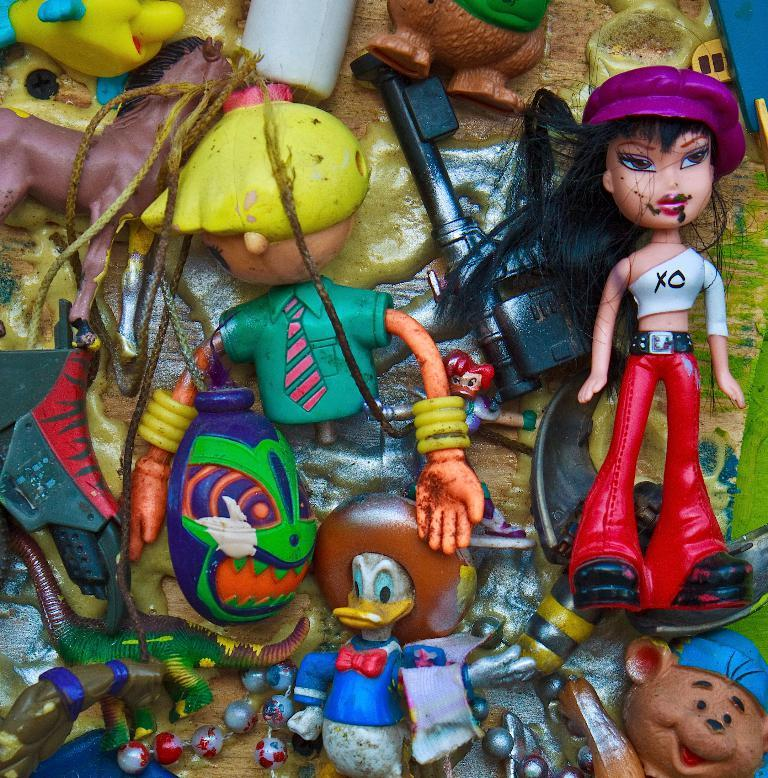What type of objects can be seen in the image? There are many toys in the image, including a doll and a horse toy. Can you identify any specific characters in the image? Yes, Donald Duck is present in the image. What color is the lip on the doll in the image? There is no lip present on the doll in the image. Are there any cobwebs visible in the image? There is no mention of cobwebs in the provided facts, and therefore we cannot determine if any are present in the image. 